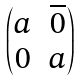<formula> <loc_0><loc_0><loc_500><loc_500>\begin{pmatrix} a & \overline { 0 } \\ 0 & a \end{pmatrix}</formula> 